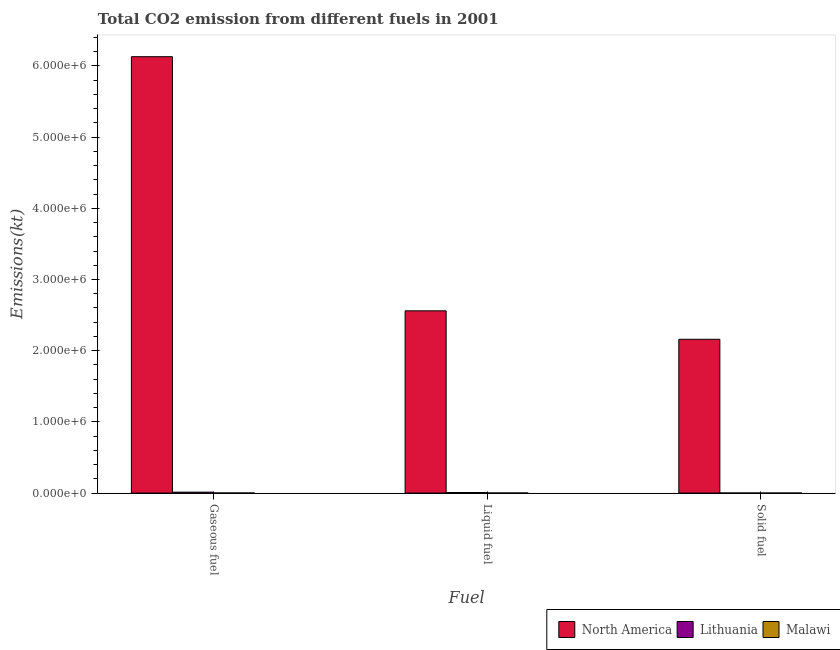How many different coloured bars are there?
Your answer should be compact. 3. Are the number of bars on each tick of the X-axis equal?
Provide a succinct answer. Yes. How many bars are there on the 3rd tick from the left?
Offer a very short reply. 3. How many bars are there on the 3rd tick from the right?
Ensure brevity in your answer.  3. What is the label of the 2nd group of bars from the left?
Give a very brief answer. Liquid fuel. What is the amount of co2 emissions from solid fuel in North America?
Make the answer very short. 2.16e+06. Across all countries, what is the maximum amount of co2 emissions from gaseous fuel?
Offer a very short reply. 6.13e+06. Across all countries, what is the minimum amount of co2 emissions from solid fuel?
Your answer should be compact. 121.01. In which country was the amount of co2 emissions from liquid fuel minimum?
Offer a terse response. Malawi. What is the total amount of co2 emissions from gaseous fuel in the graph?
Give a very brief answer. 6.14e+06. What is the difference between the amount of co2 emissions from liquid fuel in Malawi and that in Lithuania?
Ensure brevity in your answer.  -6677.61. What is the difference between the amount of co2 emissions from solid fuel in Malawi and the amount of co2 emissions from gaseous fuel in Lithuania?
Provide a short and direct response. -1.28e+04. What is the average amount of co2 emissions from liquid fuel per country?
Your response must be concise. 8.56e+05. What is the difference between the amount of co2 emissions from gaseous fuel and amount of co2 emissions from liquid fuel in Malawi?
Make the answer very short. 216.35. What is the ratio of the amount of co2 emissions from liquid fuel in North America to that in Lithuania?
Ensure brevity in your answer.  347.49. Is the difference between the amount of co2 emissions from gaseous fuel in Malawi and Lithuania greater than the difference between the amount of co2 emissions from liquid fuel in Malawi and Lithuania?
Your answer should be compact. No. What is the difference between the highest and the second highest amount of co2 emissions from solid fuel?
Your answer should be compact. 2.16e+06. What is the difference between the highest and the lowest amount of co2 emissions from solid fuel?
Your answer should be very brief. 2.16e+06. In how many countries, is the amount of co2 emissions from gaseous fuel greater than the average amount of co2 emissions from gaseous fuel taken over all countries?
Offer a very short reply. 1. How many bars are there?
Your response must be concise. 9. How many countries are there in the graph?
Offer a terse response. 3. What is the difference between two consecutive major ticks on the Y-axis?
Offer a terse response. 1.00e+06. Does the graph contain grids?
Offer a terse response. No. Where does the legend appear in the graph?
Give a very brief answer. Bottom right. How many legend labels are there?
Keep it short and to the point. 3. How are the legend labels stacked?
Make the answer very short. Horizontal. What is the title of the graph?
Your answer should be very brief. Total CO2 emission from different fuels in 2001. What is the label or title of the X-axis?
Keep it short and to the point. Fuel. What is the label or title of the Y-axis?
Keep it short and to the point. Emissions(kt). What is the Emissions(kt) in North America in Gaseous fuel?
Provide a short and direct response. 6.13e+06. What is the Emissions(kt) in Lithuania in Gaseous fuel?
Provide a short and direct response. 1.29e+04. What is the Emissions(kt) in Malawi in Gaseous fuel?
Offer a terse response. 905.75. What is the Emissions(kt) of North America in Liquid fuel?
Give a very brief answer. 2.56e+06. What is the Emissions(kt) in Lithuania in Liquid fuel?
Make the answer very short. 7367. What is the Emissions(kt) in Malawi in Liquid fuel?
Keep it short and to the point. 689.4. What is the Emissions(kt) of North America in Solid fuel?
Ensure brevity in your answer.  2.16e+06. What is the Emissions(kt) in Lithuania in Solid fuel?
Make the answer very short. 374.03. What is the Emissions(kt) in Malawi in Solid fuel?
Keep it short and to the point. 121.01. Across all Fuel, what is the maximum Emissions(kt) in North America?
Ensure brevity in your answer.  6.13e+06. Across all Fuel, what is the maximum Emissions(kt) of Lithuania?
Keep it short and to the point. 1.29e+04. Across all Fuel, what is the maximum Emissions(kt) of Malawi?
Your response must be concise. 905.75. Across all Fuel, what is the minimum Emissions(kt) in North America?
Provide a succinct answer. 2.16e+06. Across all Fuel, what is the minimum Emissions(kt) in Lithuania?
Your answer should be compact. 374.03. Across all Fuel, what is the minimum Emissions(kt) of Malawi?
Your response must be concise. 121.01. What is the total Emissions(kt) of North America in the graph?
Offer a very short reply. 1.09e+07. What is the total Emissions(kt) in Lithuania in the graph?
Ensure brevity in your answer.  2.07e+04. What is the total Emissions(kt) in Malawi in the graph?
Offer a terse response. 1716.16. What is the difference between the Emissions(kt) of North America in Gaseous fuel and that in Liquid fuel?
Ensure brevity in your answer.  3.57e+06. What is the difference between the Emissions(kt) of Lithuania in Gaseous fuel and that in Liquid fuel?
Your answer should be compact. 5551.84. What is the difference between the Emissions(kt) of Malawi in Gaseous fuel and that in Liquid fuel?
Make the answer very short. 216.35. What is the difference between the Emissions(kt) of North America in Gaseous fuel and that in Solid fuel?
Make the answer very short. 3.97e+06. What is the difference between the Emissions(kt) in Lithuania in Gaseous fuel and that in Solid fuel?
Offer a very short reply. 1.25e+04. What is the difference between the Emissions(kt) of Malawi in Gaseous fuel and that in Solid fuel?
Your response must be concise. 784.74. What is the difference between the Emissions(kt) of North America in Liquid fuel and that in Solid fuel?
Ensure brevity in your answer.  4.00e+05. What is the difference between the Emissions(kt) in Lithuania in Liquid fuel and that in Solid fuel?
Offer a very short reply. 6992.97. What is the difference between the Emissions(kt) in Malawi in Liquid fuel and that in Solid fuel?
Provide a short and direct response. 568.38. What is the difference between the Emissions(kt) of North America in Gaseous fuel and the Emissions(kt) of Lithuania in Liquid fuel?
Your answer should be very brief. 6.12e+06. What is the difference between the Emissions(kt) of North America in Gaseous fuel and the Emissions(kt) of Malawi in Liquid fuel?
Ensure brevity in your answer.  6.13e+06. What is the difference between the Emissions(kt) of Lithuania in Gaseous fuel and the Emissions(kt) of Malawi in Liquid fuel?
Provide a short and direct response. 1.22e+04. What is the difference between the Emissions(kt) of North America in Gaseous fuel and the Emissions(kt) of Lithuania in Solid fuel?
Offer a terse response. 6.13e+06. What is the difference between the Emissions(kt) in North America in Gaseous fuel and the Emissions(kt) in Malawi in Solid fuel?
Provide a short and direct response. 6.13e+06. What is the difference between the Emissions(kt) in Lithuania in Gaseous fuel and the Emissions(kt) in Malawi in Solid fuel?
Keep it short and to the point. 1.28e+04. What is the difference between the Emissions(kt) of North America in Liquid fuel and the Emissions(kt) of Lithuania in Solid fuel?
Keep it short and to the point. 2.56e+06. What is the difference between the Emissions(kt) of North America in Liquid fuel and the Emissions(kt) of Malawi in Solid fuel?
Give a very brief answer. 2.56e+06. What is the difference between the Emissions(kt) in Lithuania in Liquid fuel and the Emissions(kt) in Malawi in Solid fuel?
Make the answer very short. 7245.99. What is the average Emissions(kt) in North America per Fuel?
Provide a short and direct response. 3.62e+06. What is the average Emissions(kt) of Lithuania per Fuel?
Your answer should be very brief. 6886.63. What is the average Emissions(kt) in Malawi per Fuel?
Provide a short and direct response. 572.05. What is the difference between the Emissions(kt) in North America and Emissions(kt) in Lithuania in Gaseous fuel?
Offer a very short reply. 6.12e+06. What is the difference between the Emissions(kt) in North America and Emissions(kt) in Malawi in Gaseous fuel?
Give a very brief answer. 6.13e+06. What is the difference between the Emissions(kt) in Lithuania and Emissions(kt) in Malawi in Gaseous fuel?
Offer a terse response. 1.20e+04. What is the difference between the Emissions(kt) of North America and Emissions(kt) of Lithuania in Liquid fuel?
Your answer should be very brief. 2.55e+06. What is the difference between the Emissions(kt) of North America and Emissions(kt) of Malawi in Liquid fuel?
Provide a succinct answer. 2.56e+06. What is the difference between the Emissions(kt) of Lithuania and Emissions(kt) of Malawi in Liquid fuel?
Ensure brevity in your answer.  6677.61. What is the difference between the Emissions(kt) of North America and Emissions(kt) of Lithuania in Solid fuel?
Keep it short and to the point. 2.16e+06. What is the difference between the Emissions(kt) in North America and Emissions(kt) in Malawi in Solid fuel?
Your response must be concise. 2.16e+06. What is the difference between the Emissions(kt) of Lithuania and Emissions(kt) of Malawi in Solid fuel?
Offer a very short reply. 253.02. What is the ratio of the Emissions(kt) in North America in Gaseous fuel to that in Liquid fuel?
Offer a very short reply. 2.39. What is the ratio of the Emissions(kt) of Lithuania in Gaseous fuel to that in Liquid fuel?
Give a very brief answer. 1.75. What is the ratio of the Emissions(kt) of Malawi in Gaseous fuel to that in Liquid fuel?
Offer a very short reply. 1.31. What is the ratio of the Emissions(kt) in North America in Gaseous fuel to that in Solid fuel?
Offer a terse response. 2.84. What is the ratio of the Emissions(kt) in Lithuania in Gaseous fuel to that in Solid fuel?
Offer a very short reply. 34.54. What is the ratio of the Emissions(kt) of Malawi in Gaseous fuel to that in Solid fuel?
Your answer should be very brief. 7.48. What is the ratio of the Emissions(kt) of North America in Liquid fuel to that in Solid fuel?
Give a very brief answer. 1.19. What is the ratio of the Emissions(kt) in Lithuania in Liquid fuel to that in Solid fuel?
Your response must be concise. 19.7. What is the ratio of the Emissions(kt) in Malawi in Liquid fuel to that in Solid fuel?
Make the answer very short. 5.7. What is the difference between the highest and the second highest Emissions(kt) of North America?
Keep it short and to the point. 3.57e+06. What is the difference between the highest and the second highest Emissions(kt) in Lithuania?
Keep it short and to the point. 5551.84. What is the difference between the highest and the second highest Emissions(kt) of Malawi?
Provide a succinct answer. 216.35. What is the difference between the highest and the lowest Emissions(kt) in North America?
Offer a very short reply. 3.97e+06. What is the difference between the highest and the lowest Emissions(kt) of Lithuania?
Your answer should be compact. 1.25e+04. What is the difference between the highest and the lowest Emissions(kt) in Malawi?
Offer a very short reply. 784.74. 